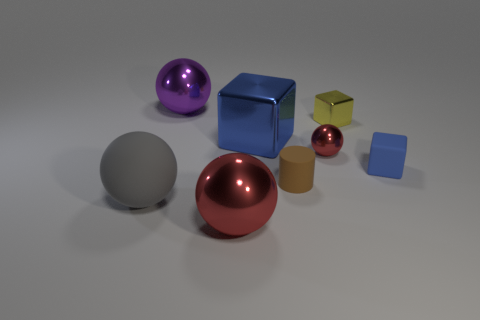Is there anything else that has the same material as the brown object?
Make the answer very short. Yes. There is a big metallic thing that is in front of the tiny blue block; is it the same color as the small ball?
Give a very brief answer. Yes. Is there a metal thing of the same color as the matte cube?
Your answer should be very brief. Yes. Is the number of purple balls right of the large blue shiny object the same as the number of brown things?
Your answer should be very brief. No. Is the color of the big metal block the same as the small rubber cube?
Offer a terse response. Yes. What is the size of the object that is to the right of the small shiny ball and in front of the big blue object?
Offer a very short reply. Small. What is the color of the small cube that is the same material as the tiny brown thing?
Your answer should be compact. Blue. How many blue blocks have the same material as the yellow object?
Give a very brief answer. 1. Are there an equal number of tiny yellow shiny blocks left of the tiny sphere and tiny blue objects that are behind the small yellow thing?
Offer a terse response. Yes. There is a large matte object; is its shape the same as the big shiny thing that is behind the tiny yellow metal cube?
Give a very brief answer. Yes. 